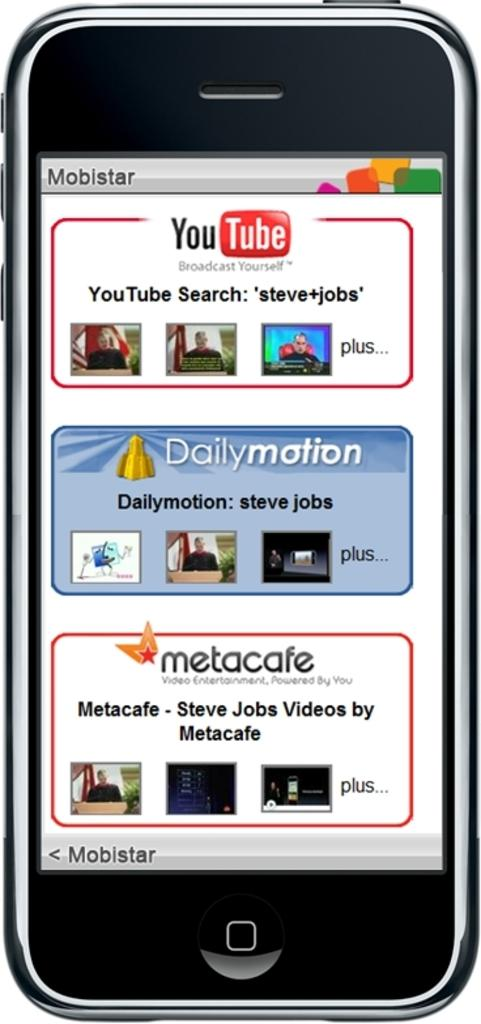<image>
Relay a brief, clear account of the picture shown. a smart phone with a tab for daily motion in the middle. 